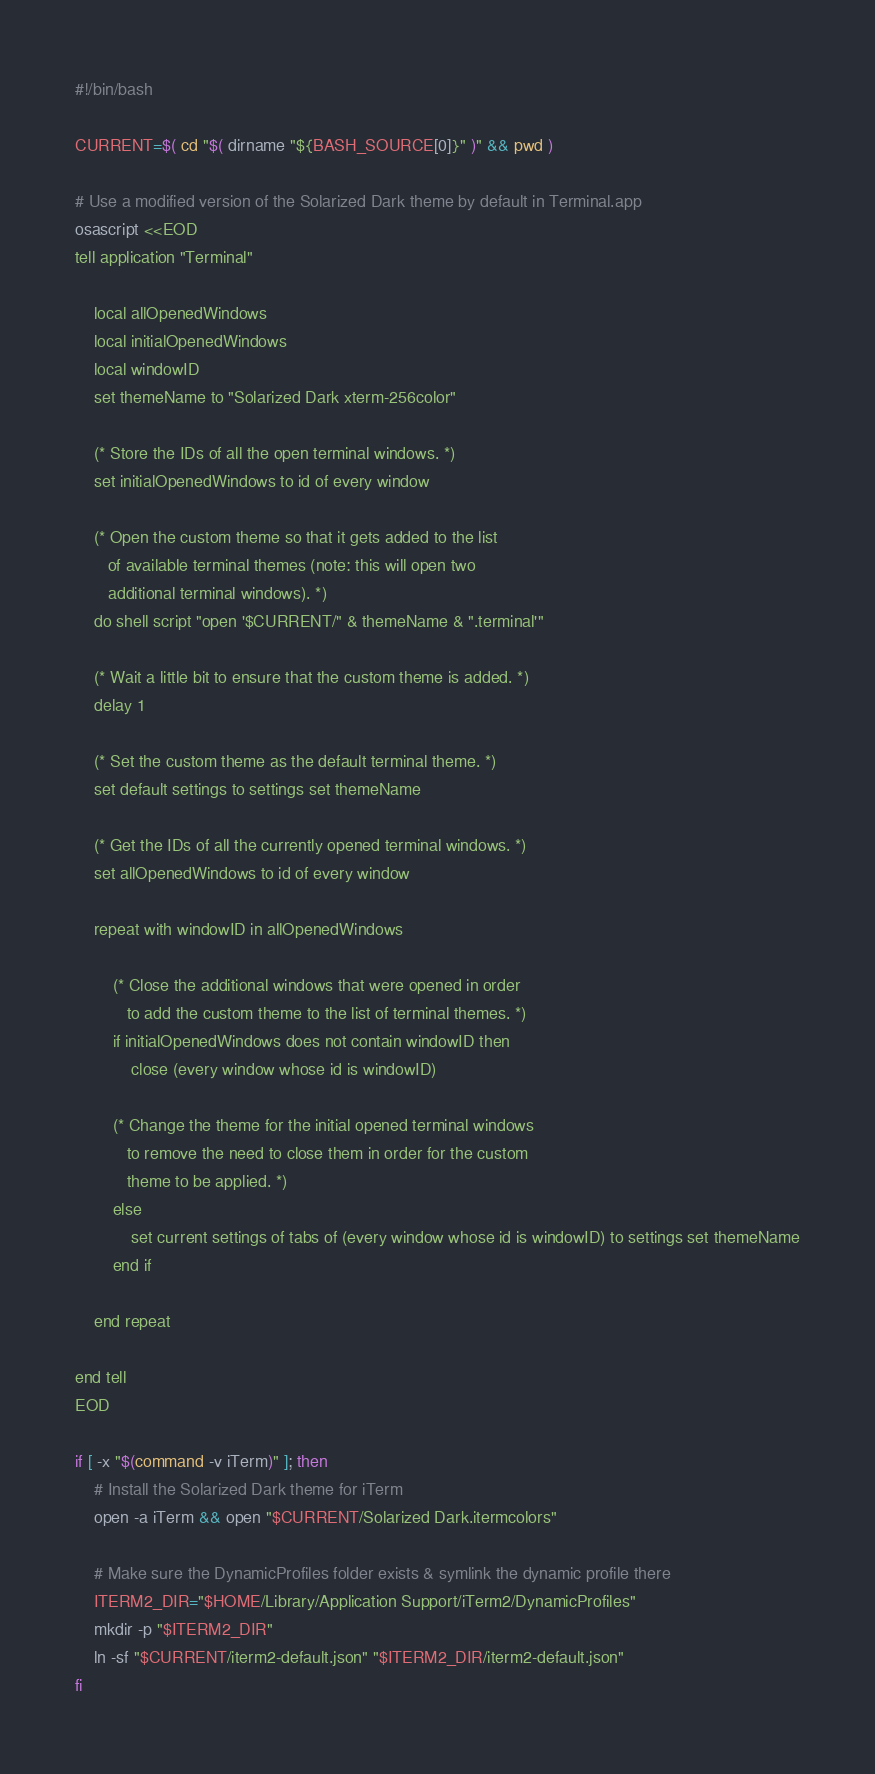Convert code to text. <code><loc_0><loc_0><loc_500><loc_500><_Bash_>#!/bin/bash

CURRENT=$( cd "$( dirname "${BASH_SOURCE[0]}" )" && pwd )

# Use a modified version of the Solarized Dark theme by default in Terminal.app
osascript <<EOD
tell application "Terminal"

	local allOpenedWindows
	local initialOpenedWindows
	local windowID
	set themeName to "Solarized Dark xterm-256color"

	(* Store the IDs of all the open terminal windows. *)
	set initialOpenedWindows to id of every window

	(* Open the custom theme so that it gets added to the list
	   of available terminal themes (note: this will open two
	   additional terminal windows). *)
	do shell script "open '$CURRENT/" & themeName & ".terminal'"

	(* Wait a little bit to ensure that the custom theme is added. *)
	delay 1

	(* Set the custom theme as the default terminal theme. *)
	set default settings to settings set themeName

	(* Get the IDs of all the currently opened terminal windows. *)
	set allOpenedWindows to id of every window

	repeat with windowID in allOpenedWindows

		(* Close the additional windows that were opened in order
		   to add the custom theme to the list of terminal themes. *)
		if initialOpenedWindows does not contain windowID then
			close (every window whose id is windowID)

		(* Change the theme for the initial opened terminal windows
		   to remove the need to close them in order for the custom
		   theme to be applied. *)
		else
			set current settings of tabs of (every window whose id is windowID) to settings set themeName
		end if

	end repeat

end tell
EOD

if [ -x "$(command -v iTerm)" ]; then
    # Install the Solarized Dark theme for iTerm
    open -a iTerm && open "$CURRENT/Solarized Dark.itermcolors"

    # Make sure the DynamicProfiles folder exists & symlink the dynamic profile there
    ITERM2_DIR="$HOME/Library/Application Support/iTerm2/DynamicProfiles"
    mkdir -p "$ITERM2_DIR"
    ln -sf "$CURRENT/iterm2-default.json" "$ITERM2_DIR/iterm2-default.json"
fi</code> 